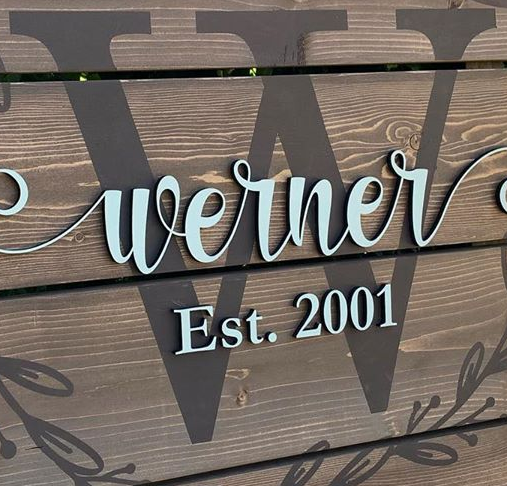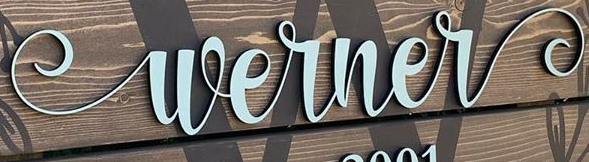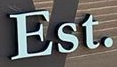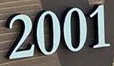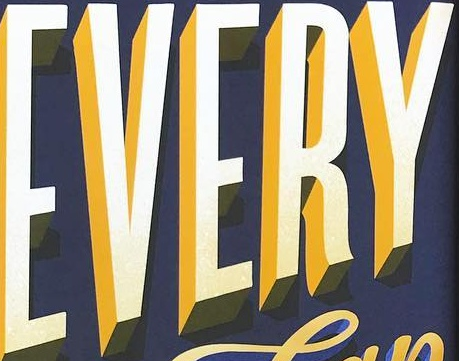Identify the words shown in these images in order, separated by a semicolon. W; Werner; Est.; 2001; EVERY 